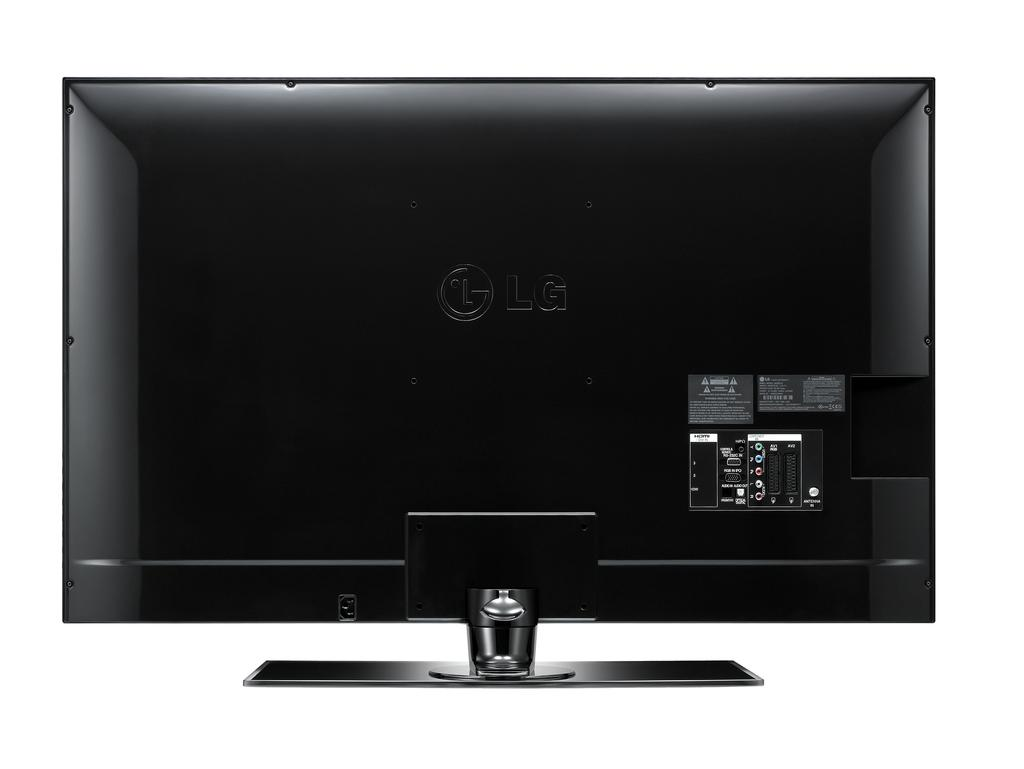<image>
Relay a brief, clear account of the picture shown. an LG monitor that is all black in color 